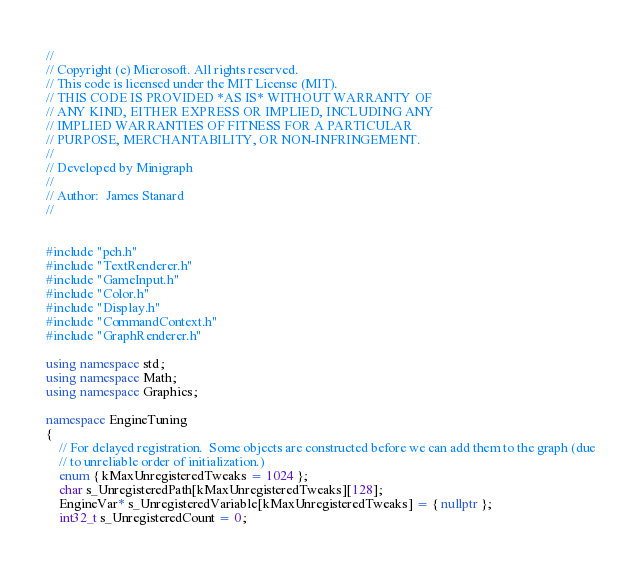Convert code to text. <code><loc_0><loc_0><loc_500><loc_500><_C++_>//
// Copyright (c) Microsoft. All rights reserved.
// This code is licensed under the MIT License (MIT).
// THIS CODE IS PROVIDED *AS IS* WITHOUT WARRANTY OF
// ANY KIND, EITHER EXPRESS OR IMPLIED, INCLUDING ANY
// IMPLIED WARRANTIES OF FITNESS FOR A PARTICULAR
// PURPOSE, MERCHANTABILITY, OR NON-INFRINGEMENT.
//
// Developed by Minigraph
//
// Author:  James Stanard 
//


#include "pch.h"
#include "TextRenderer.h"
#include "GameInput.h"
#include "Color.h"
#include "Display.h"
#include "CommandContext.h"
#include "GraphRenderer.h"

using namespace std;
using namespace Math;
using namespace Graphics;

namespace EngineTuning
{
	// For delayed registration.  Some objects are constructed before we can add them to the graph (due
	// to unreliable order of initialization.)
	enum { kMaxUnregisteredTweaks = 1024 };
	char s_UnregisteredPath[kMaxUnregisteredTweaks][128];
	EngineVar* s_UnregisteredVariable[kMaxUnregisteredTweaks] = { nullptr };
	int32_t s_UnregisteredCount = 0;</code> 